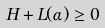Convert formula to latex. <formula><loc_0><loc_0><loc_500><loc_500>H + L ( \alpha ) \geq 0</formula> 